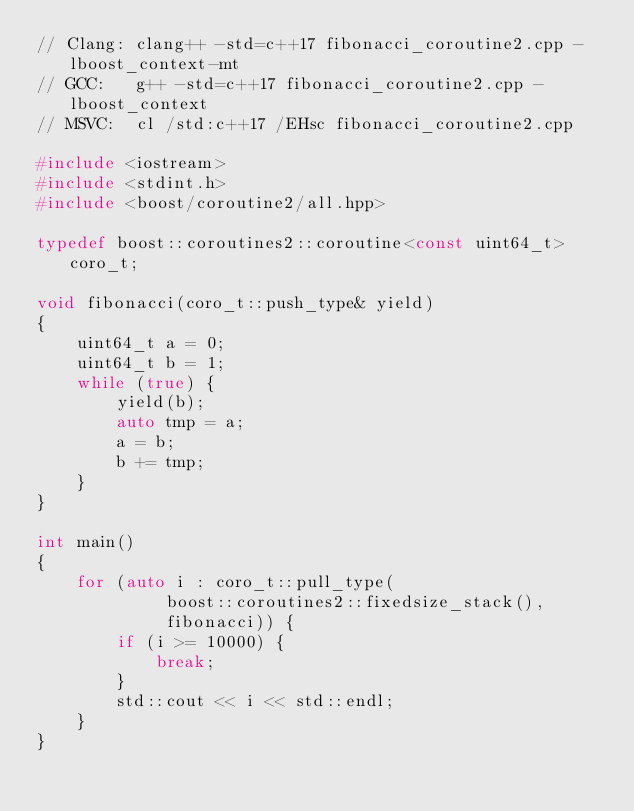<code> <loc_0><loc_0><loc_500><loc_500><_C++_>// Clang: clang++ -std=c++17 fibonacci_coroutine2.cpp -lboost_context-mt
// GCC:   g++ -std=c++17 fibonacci_coroutine2.cpp -lboost_context
// MSVC:  cl /std:c++17 /EHsc fibonacci_coroutine2.cpp

#include <iostream>
#include <stdint.h>
#include <boost/coroutine2/all.hpp>

typedef boost::coroutines2::coroutine<const uint64_t> coro_t;

void fibonacci(coro_t::push_type& yield)
{
    uint64_t a = 0;
    uint64_t b = 1;
    while (true) {
        yield(b);
        auto tmp = a;
        a = b;
        b += tmp;
    }
}

int main()
{
    for (auto i : coro_t::pull_type(
             boost::coroutines2::fixedsize_stack(),
             fibonacci)) {
        if (i >= 10000) {
            break;
        }
        std::cout << i << std::endl;
    }
}
</code> 